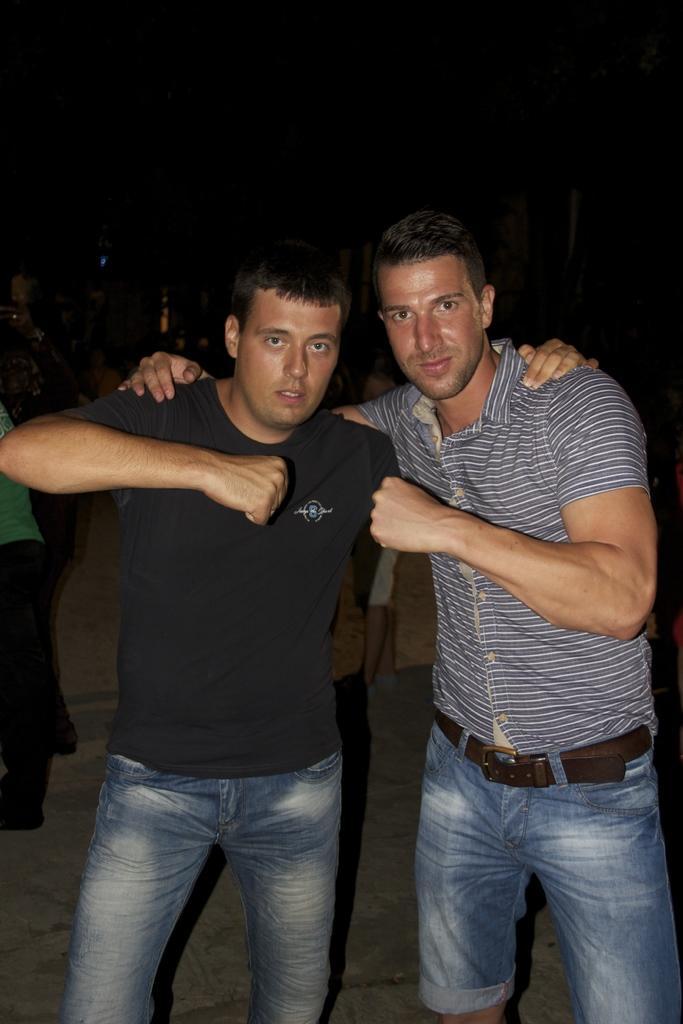Please provide a concise description of this image. Here I can see two men standing and giving pose for the picture. In the background, I can see some more people standing in the dark. 